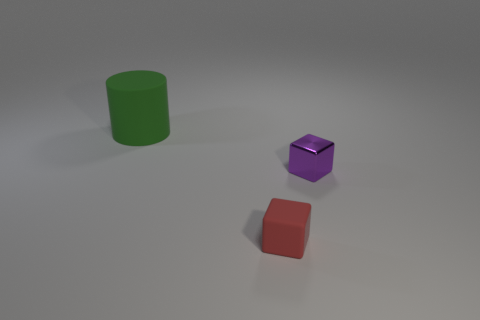How big is the matte object that is behind the rubber thing that is in front of the green cylinder?
Keep it short and to the point. Large. Is the shape of the small thing that is on the left side of the purple thing the same as the thing that is on the left side of the red block?
Offer a terse response. No. What shape is the rubber object in front of the large green thing left of the purple cube?
Make the answer very short. Cube. There is a thing that is both to the left of the purple shiny block and behind the red object; how big is it?
Offer a very short reply. Large. There is a green object; does it have the same shape as the small object on the left side of the tiny purple block?
Your answer should be very brief. No. There is a red thing that is the same shape as the purple thing; what size is it?
Provide a short and direct response. Small. There is a cylinder; does it have the same color as the cube in front of the small purple object?
Give a very brief answer. No. How many other things are the same size as the green rubber thing?
Provide a succinct answer. 0. What is the shape of the tiny object that is behind the small object that is left of the small thing that is behind the red block?
Offer a very short reply. Cube. Do the red rubber block and the rubber thing that is left of the red thing have the same size?
Offer a terse response. No. 